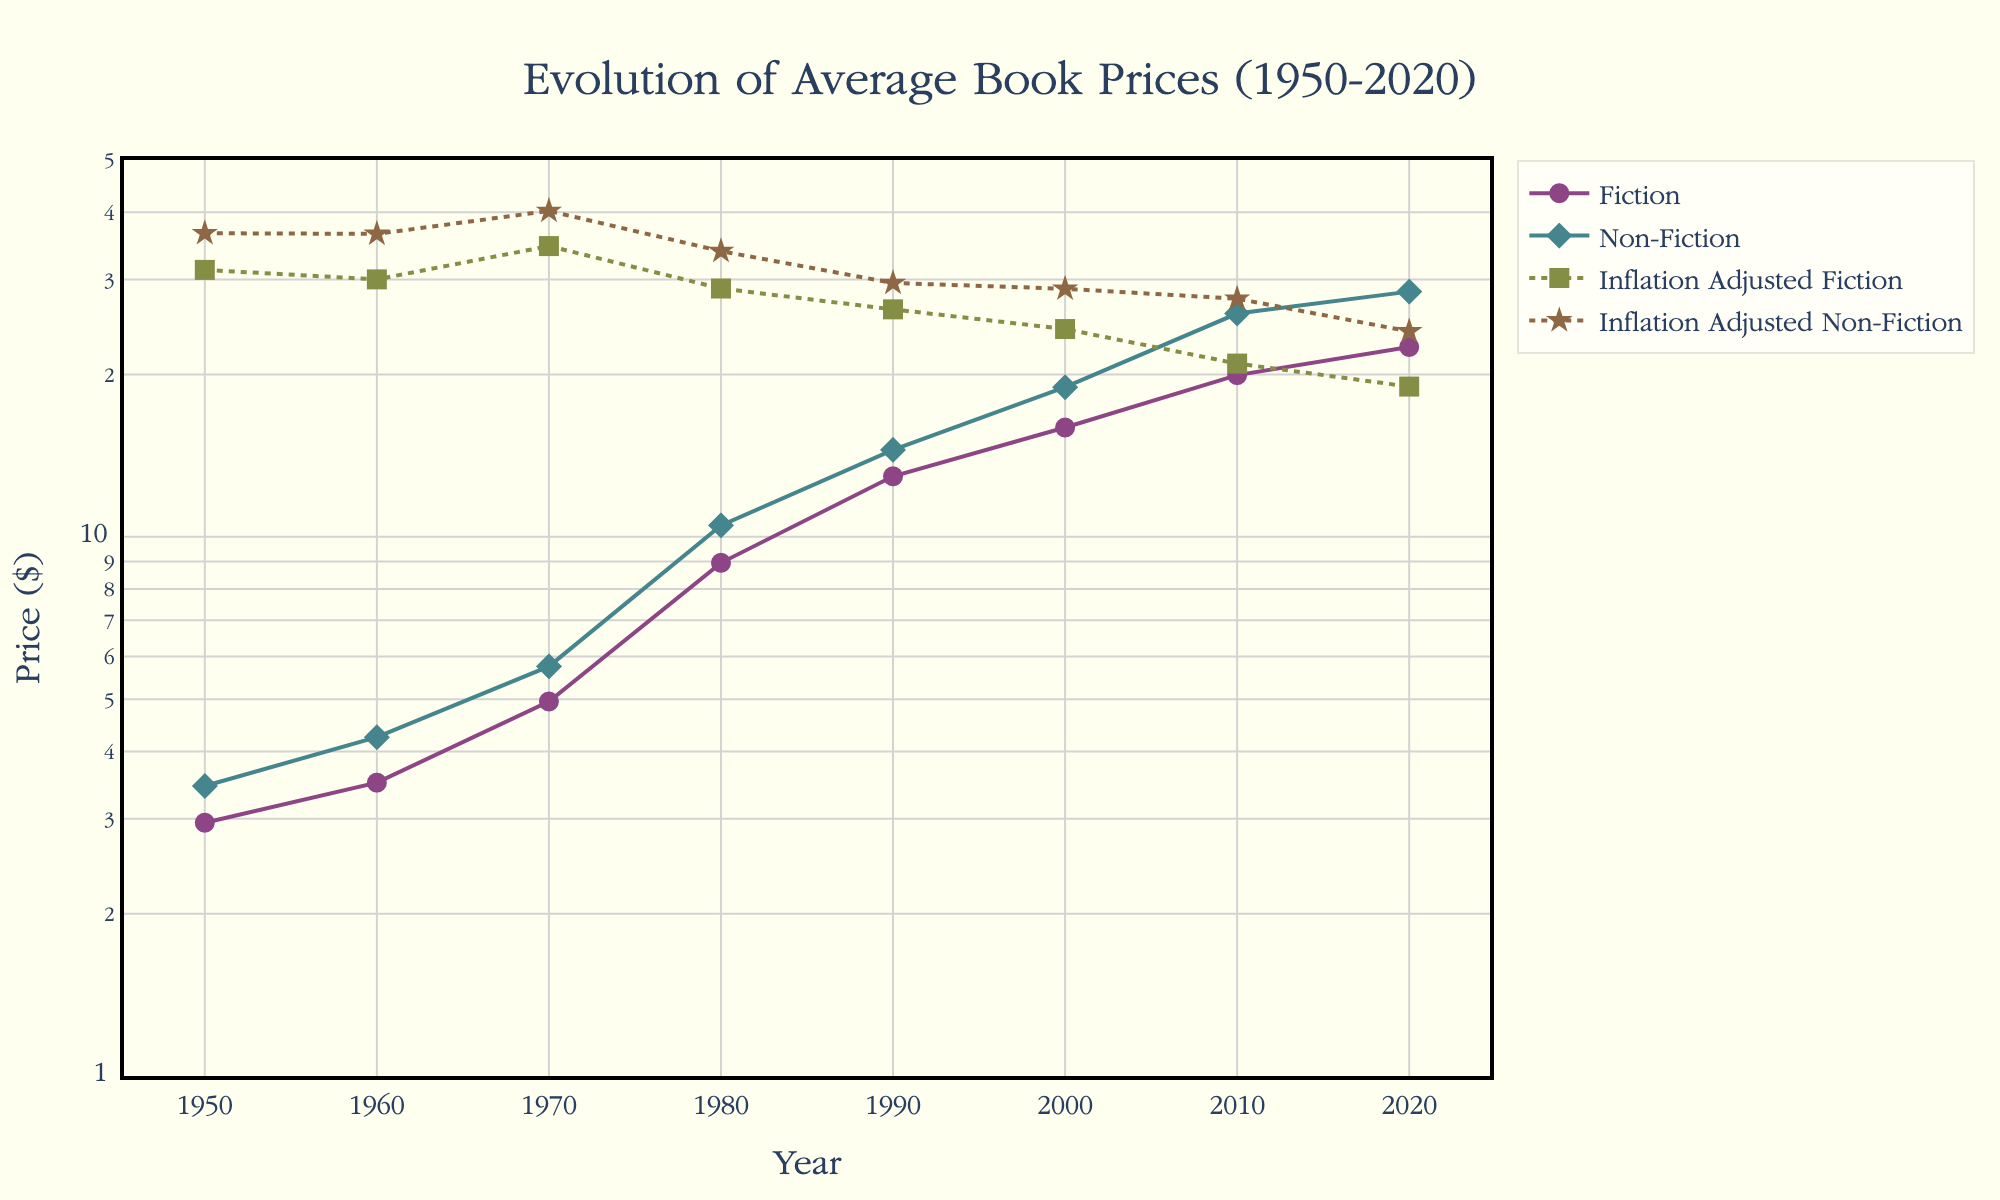What is the general trend of book prices over the decades? To find the general trend, observe the markers and lines for both Fiction and Non-Fiction prices across the years. Both types of book prices generally increase as we move from 1950 to 2020.
Answer: Increasing What price was higher in 2020, Fiction or Non-Fiction? In 2020, the marker for Non-Fiction is higher on the y-axis compared to the marker for Fiction, indicating Non-Fiction prices were higher.
Answer: Non-Fiction How did the inflation-adjusted price of Fiction books change from 1950 to 2020? Observe the Inflation Adjusted Fiction line's position from 1950 to 2020. The line starts higher in 1950 and drops to a lower value in 2020.
Answer: Decreased Did Fiction or Non-Fiction prices show more fluctuation over the decades? Compare the vertical movement in the Fiction and Non-Fiction price lines over the decades. Non-Fiction prices show more fluctuation with more sizeable upward and downward changes.
Answer: Non-Fiction Which year had the highest inflation-adjusted Non-Fiction price? Look at the Inflation Adjusted Non-Fiction line and identify the year where the marker is at the highest position on the y-axis. That's 1950.
Answer: 1950 What is the approximate range of the Inflation Adjusted Fiction prices over the decades? Identify the highest and lowest points of the Inflation Adjusted Fiction line. The highest point is around 1950 (31.27), and the lowest is around 2020 (19.00).
Answer: 19.00 to 31.27 By how much did Fiction book prices increase from 1950 to 2020? Subtract the Fiction price in 1950 (2.95) from the Fiction price in 2020 (22.50). 22.50 - 2.95 = 19.55
Answer: 19.55 Which year had the smallest gap between Fiction and Non-Fiction prices? Calculate the differences between Fiction and Non-Fiction prices for each year by checking the markers and lines. The smallest gap appears in 1990 (14.50 - 12.95 = 1.55).
Answer: 1990 Did the inflation adjustment result in both Fiction and Non-Fiction prices generally decreasing over time? Observe the Inflation Adjusted Fiction and Non-Fiction lines from the start to the end period. Both lines show a downward trend.
Answer: Yes If one were to make predictions based on the trend, would Non-Fiction prices continue to rise? Based on the visible upward trend in Non-Fiction prices over the decades, it is reasonable to predict continued increases.
Answer: Yes 